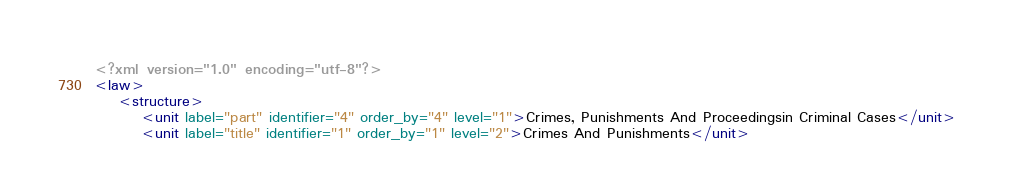<code> <loc_0><loc_0><loc_500><loc_500><_XML_><?xml version="1.0" encoding="utf-8"?>
<law>
    <structure>
        <unit label="part" identifier="4" order_by="4" level="1">Crimes, Punishments And Proceedingsin Criminal Cases</unit>
        <unit label="title" identifier="1" order_by="1" level="2">Crimes And Punishments</unit></code> 